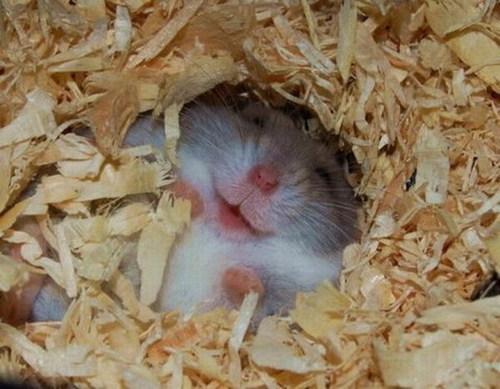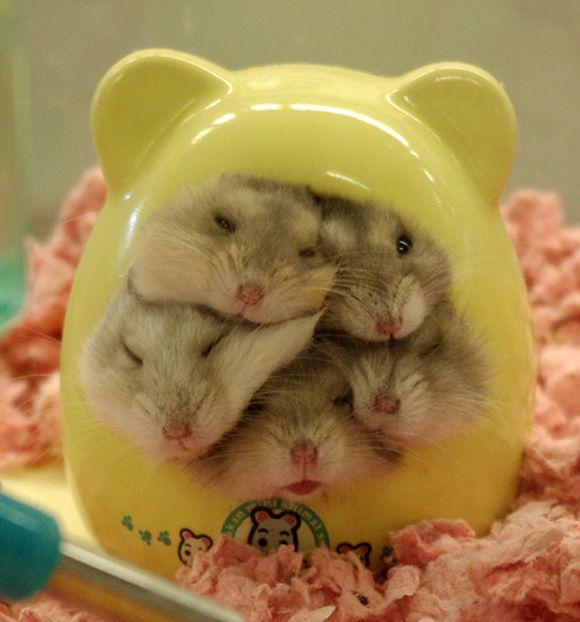The first image is the image on the left, the second image is the image on the right. Evaluate the accuracy of this statement regarding the images: "There are no more than three rodents". Is it true? Answer yes or no. No. The first image is the image on the left, the second image is the image on the right. For the images shown, is this caption "One image shows a cluster of pets inside something with ears." true? Answer yes or no. Yes. 